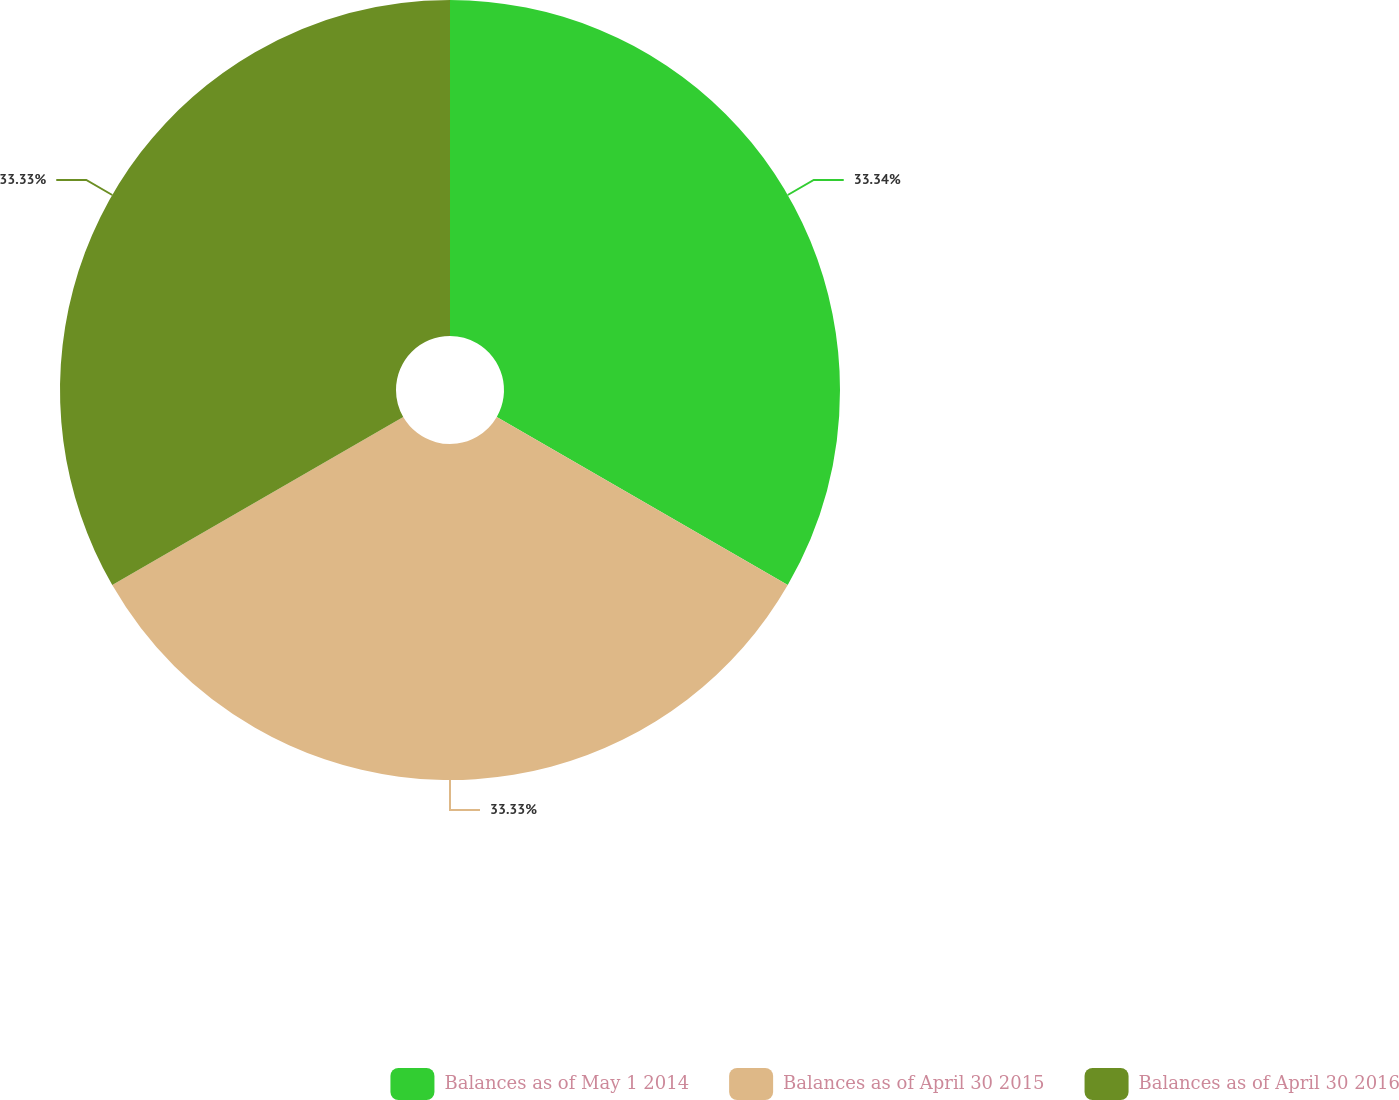Convert chart. <chart><loc_0><loc_0><loc_500><loc_500><pie_chart><fcel>Balances as of May 1 2014<fcel>Balances as of April 30 2015<fcel>Balances as of April 30 2016<nl><fcel>33.33%<fcel>33.33%<fcel>33.33%<nl></chart> 